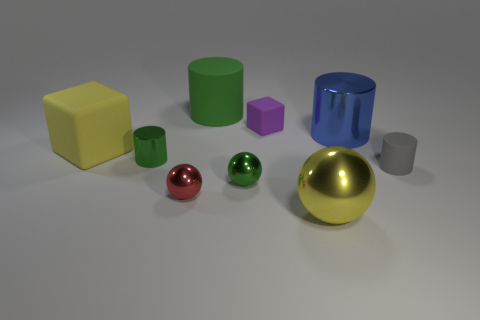Do the tiny rubber thing in front of the big shiny cylinder and the large green matte thing have the same shape?
Your answer should be compact. Yes. What is the color of the shiny cylinder to the left of the big blue metallic object?
Keep it short and to the point. Green. How many blocks are large matte things or purple rubber objects?
Make the answer very short. 2. There is a green shiny object in front of the cylinder that is left of the large green object; what is its size?
Your answer should be compact. Small. There is a large metallic cylinder; is its color the same as the large metallic thing that is in front of the blue metal cylinder?
Your answer should be compact. No. There is a large yellow metallic ball; what number of tiny cubes are left of it?
Give a very brief answer. 1. Is the number of tiny purple cubes less than the number of rubber cylinders?
Your answer should be very brief. Yes. There is a metal object that is behind the red metal sphere and to the left of the large green cylinder; what is its size?
Give a very brief answer. Small. There is a rubber cylinder that is behind the blue metal cylinder; does it have the same color as the big metallic sphere?
Your response must be concise. No. Is the number of gray things left of the yellow rubber thing less than the number of large blue things?
Your answer should be compact. Yes. 